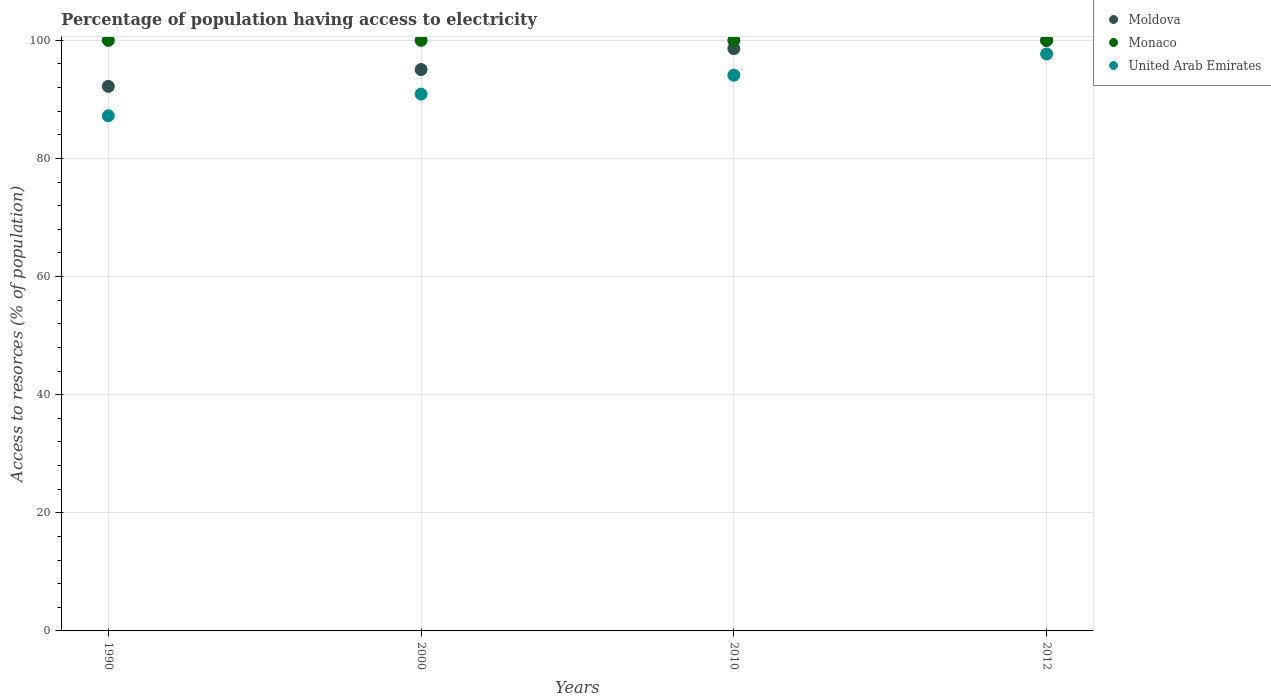Is the number of dotlines equal to the number of legend labels?
Provide a short and direct response. Yes. What is the percentage of population having access to electricity in United Arab Emirates in 2010?
Your answer should be compact. 94.1. Across all years, what is the maximum percentage of population having access to electricity in Moldova?
Keep it short and to the point. 100. Across all years, what is the minimum percentage of population having access to electricity in Monaco?
Ensure brevity in your answer.  100. In which year was the percentage of population having access to electricity in Moldova maximum?
Make the answer very short. 2012. In which year was the percentage of population having access to electricity in United Arab Emirates minimum?
Your answer should be compact. 1990. What is the total percentage of population having access to electricity in United Arab Emirates in the graph?
Your response must be concise. 369.92. What is the difference between the percentage of population having access to electricity in Monaco in 1990 and that in 2010?
Your response must be concise. 0. What is the difference between the percentage of population having access to electricity in Monaco in 2000 and the percentage of population having access to electricity in United Arab Emirates in 2012?
Make the answer very short. 2.3. What is the average percentage of population having access to electricity in Moldova per year?
Provide a succinct answer. 96.47. In the year 1990, what is the difference between the percentage of population having access to electricity in Monaco and percentage of population having access to electricity in United Arab Emirates?
Offer a very short reply. 12.77. In how many years, is the percentage of population having access to electricity in United Arab Emirates greater than 44 %?
Ensure brevity in your answer.  4. Is the difference between the percentage of population having access to electricity in Monaco in 2000 and 2012 greater than the difference between the percentage of population having access to electricity in United Arab Emirates in 2000 and 2012?
Your response must be concise. Yes. What is the difference between the highest and the second highest percentage of population having access to electricity in Moldova?
Ensure brevity in your answer.  1.4. What is the difference between the highest and the lowest percentage of population having access to electricity in United Arab Emirates?
Your answer should be compact. 10.47. Is it the case that in every year, the sum of the percentage of population having access to electricity in Monaco and percentage of population having access to electricity in United Arab Emirates  is greater than the percentage of population having access to electricity in Moldova?
Make the answer very short. Yes. Is the percentage of population having access to electricity in Moldova strictly less than the percentage of population having access to electricity in United Arab Emirates over the years?
Give a very brief answer. No. What is the difference between two consecutive major ticks on the Y-axis?
Ensure brevity in your answer.  20. Does the graph contain grids?
Provide a short and direct response. Yes. Where does the legend appear in the graph?
Offer a terse response. Top right. What is the title of the graph?
Keep it short and to the point. Percentage of population having access to electricity. Does "Venezuela" appear as one of the legend labels in the graph?
Offer a very short reply. No. What is the label or title of the Y-axis?
Your response must be concise. Access to resorces (% of population). What is the Access to resorces (% of population) of Moldova in 1990?
Your response must be concise. 92.22. What is the Access to resorces (% of population) of United Arab Emirates in 1990?
Ensure brevity in your answer.  87.23. What is the Access to resorces (% of population) of Moldova in 2000?
Keep it short and to the point. 95.06. What is the Access to resorces (% of population) of United Arab Emirates in 2000?
Your answer should be compact. 90.9. What is the Access to resorces (% of population) in Moldova in 2010?
Offer a very short reply. 98.6. What is the Access to resorces (% of population) of Monaco in 2010?
Make the answer very short. 100. What is the Access to resorces (% of population) of United Arab Emirates in 2010?
Offer a very short reply. 94.1. What is the Access to resorces (% of population) of Moldova in 2012?
Your response must be concise. 100. What is the Access to resorces (% of population) of Monaco in 2012?
Keep it short and to the point. 100. What is the Access to resorces (% of population) in United Arab Emirates in 2012?
Your answer should be very brief. 97.7. Across all years, what is the maximum Access to resorces (% of population) of Monaco?
Keep it short and to the point. 100. Across all years, what is the maximum Access to resorces (% of population) of United Arab Emirates?
Provide a succinct answer. 97.7. Across all years, what is the minimum Access to resorces (% of population) in Moldova?
Provide a short and direct response. 92.22. Across all years, what is the minimum Access to resorces (% of population) of United Arab Emirates?
Provide a succinct answer. 87.23. What is the total Access to resorces (% of population) of Moldova in the graph?
Keep it short and to the point. 385.87. What is the total Access to resorces (% of population) of Monaco in the graph?
Offer a very short reply. 400. What is the total Access to resorces (% of population) of United Arab Emirates in the graph?
Your answer should be compact. 369.92. What is the difference between the Access to resorces (% of population) of Moldova in 1990 and that in 2000?
Make the answer very short. -2.84. What is the difference between the Access to resorces (% of population) in United Arab Emirates in 1990 and that in 2000?
Your answer should be compact. -3.67. What is the difference between the Access to resorces (% of population) in Moldova in 1990 and that in 2010?
Offer a terse response. -6.38. What is the difference between the Access to resorces (% of population) in Monaco in 1990 and that in 2010?
Ensure brevity in your answer.  0. What is the difference between the Access to resorces (% of population) of United Arab Emirates in 1990 and that in 2010?
Give a very brief answer. -6.87. What is the difference between the Access to resorces (% of population) in Moldova in 1990 and that in 2012?
Ensure brevity in your answer.  -7.78. What is the difference between the Access to resorces (% of population) of Monaco in 1990 and that in 2012?
Provide a succinct answer. 0. What is the difference between the Access to resorces (% of population) in United Arab Emirates in 1990 and that in 2012?
Provide a succinct answer. -10.47. What is the difference between the Access to resorces (% of population) in Moldova in 2000 and that in 2010?
Keep it short and to the point. -3.54. What is the difference between the Access to resorces (% of population) in United Arab Emirates in 2000 and that in 2010?
Offer a terse response. -3.2. What is the difference between the Access to resorces (% of population) in Moldova in 2000 and that in 2012?
Your response must be concise. -4.94. What is the difference between the Access to resorces (% of population) in United Arab Emirates in 2000 and that in 2012?
Your answer should be compact. -6.8. What is the difference between the Access to resorces (% of population) in Moldova in 2010 and that in 2012?
Provide a short and direct response. -1.4. What is the difference between the Access to resorces (% of population) in United Arab Emirates in 2010 and that in 2012?
Keep it short and to the point. -3.6. What is the difference between the Access to resorces (% of population) in Moldova in 1990 and the Access to resorces (% of population) in Monaco in 2000?
Your response must be concise. -7.78. What is the difference between the Access to resorces (% of population) of Moldova in 1990 and the Access to resorces (% of population) of United Arab Emirates in 2000?
Provide a succinct answer. 1.32. What is the difference between the Access to resorces (% of population) of Monaco in 1990 and the Access to resorces (% of population) of United Arab Emirates in 2000?
Keep it short and to the point. 9.1. What is the difference between the Access to resorces (% of population) of Moldova in 1990 and the Access to resorces (% of population) of Monaco in 2010?
Your response must be concise. -7.78. What is the difference between the Access to resorces (% of population) in Moldova in 1990 and the Access to resorces (% of population) in United Arab Emirates in 2010?
Your response must be concise. -1.88. What is the difference between the Access to resorces (% of population) in Monaco in 1990 and the Access to resorces (% of population) in United Arab Emirates in 2010?
Ensure brevity in your answer.  5.9. What is the difference between the Access to resorces (% of population) in Moldova in 1990 and the Access to resorces (% of population) in Monaco in 2012?
Provide a succinct answer. -7.78. What is the difference between the Access to resorces (% of population) of Moldova in 1990 and the Access to resorces (% of population) of United Arab Emirates in 2012?
Provide a short and direct response. -5.48. What is the difference between the Access to resorces (% of population) of Monaco in 1990 and the Access to resorces (% of population) of United Arab Emirates in 2012?
Your answer should be very brief. 2.3. What is the difference between the Access to resorces (% of population) of Moldova in 2000 and the Access to resorces (% of population) of Monaco in 2010?
Give a very brief answer. -4.94. What is the difference between the Access to resorces (% of population) in Moldova in 2000 and the Access to resorces (% of population) in United Arab Emirates in 2010?
Ensure brevity in your answer.  0.96. What is the difference between the Access to resorces (% of population) of Moldova in 2000 and the Access to resorces (% of population) of Monaco in 2012?
Ensure brevity in your answer.  -4.94. What is the difference between the Access to resorces (% of population) in Moldova in 2000 and the Access to resorces (% of population) in United Arab Emirates in 2012?
Provide a succinct answer. -2.64. What is the difference between the Access to resorces (% of population) of Monaco in 2000 and the Access to resorces (% of population) of United Arab Emirates in 2012?
Give a very brief answer. 2.3. What is the difference between the Access to resorces (% of population) in Moldova in 2010 and the Access to resorces (% of population) in Monaco in 2012?
Offer a terse response. -1.4. What is the difference between the Access to resorces (% of population) of Moldova in 2010 and the Access to resorces (% of population) of United Arab Emirates in 2012?
Offer a very short reply. 0.9. What is the difference between the Access to resorces (% of population) of Monaco in 2010 and the Access to resorces (% of population) of United Arab Emirates in 2012?
Ensure brevity in your answer.  2.3. What is the average Access to resorces (% of population) of Moldova per year?
Offer a terse response. 96.47. What is the average Access to resorces (% of population) of Monaco per year?
Ensure brevity in your answer.  100. What is the average Access to resorces (% of population) of United Arab Emirates per year?
Your answer should be compact. 92.48. In the year 1990, what is the difference between the Access to resorces (% of population) in Moldova and Access to resorces (% of population) in Monaco?
Give a very brief answer. -7.78. In the year 1990, what is the difference between the Access to resorces (% of population) in Moldova and Access to resorces (% of population) in United Arab Emirates?
Your response must be concise. 4.99. In the year 1990, what is the difference between the Access to resorces (% of population) in Monaco and Access to resorces (% of population) in United Arab Emirates?
Your answer should be very brief. 12.77. In the year 2000, what is the difference between the Access to resorces (% of population) of Moldova and Access to resorces (% of population) of Monaco?
Offer a very short reply. -4.94. In the year 2000, what is the difference between the Access to resorces (% of population) in Moldova and Access to resorces (% of population) in United Arab Emirates?
Provide a short and direct response. 4.16. In the year 2000, what is the difference between the Access to resorces (% of population) of Monaco and Access to resorces (% of population) of United Arab Emirates?
Give a very brief answer. 9.1. In the year 2010, what is the difference between the Access to resorces (% of population) in Moldova and Access to resorces (% of population) in Monaco?
Provide a short and direct response. -1.4. In the year 2010, what is the difference between the Access to resorces (% of population) of Monaco and Access to resorces (% of population) of United Arab Emirates?
Ensure brevity in your answer.  5.9. In the year 2012, what is the difference between the Access to resorces (% of population) in Moldova and Access to resorces (% of population) in United Arab Emirates?
Ensure brevity in your answer.  2.3. In the year 2012, what is the difference between the Access to resorces (% of population) of Monaco and Access to resorces (% of population) of United Arab Emirates?
Ensure brevity in your answer.  2.3. What is the ratio of the Access to resorces (% of population) in Moldova in 1990 to that in 2000?
Keep it short and to the point. 0.97. What is the ratio of the Access to resorces (% of population) in Monaco in 1990 to that in 2000?
Keep it short and to the point. 1. What is the ratio of the Access to resorces (% of population) of United Arab Emirates in 1990 to that in 2000?
Your answer should be compact. 0.96. What is the ratio of the Access to resorces (% of population) of Moldova in 1990 to that in 2010?
Ensure brevity in your answer.  0.94. What is the ratio of the Access to resorces (% of population) of United Arab Emirates in 1990 to that in 2010?
Your answer should be compact. 0.93. What is the ratio of the Access to resorces (% of population) of Moldova in 1990 to that in 2012?
Ensure brevity in your answer.  0.92. What is the ratio of the Access to resorces (% of population) of Monaco in 1990 to that in 2012?
Provide a short and direct response. 1. What is the ratio of the Access to resorces (% of population) in United Arab Emirates in 1990 to that in 2012?
Ensure brevity in your answer.  0.89. What is the ratio of the Access to resorces (% of population) of Moldova in 2000 to that in 2010?
Offer a terse response. 0.96. What is the ratio of the Access to resorces (% of population) in Moldova in 2000 to that in 2012?
Provide a short and direct response. 0.95. What is the ratio of the Access to resorces (% of population) of Monaco in 2000 to that in 2012?
Your response must be concise. 1. What is the ratio of the Access to resorces (% of population) in United Arab Emirates in 2000 to that in 2012?
Keep it short and to the point. 0.93. What is the ratio of the Access to resorces (% of population) of United Arab Emirates in 2010 to that in 2012?
Offer a terse response. 0.96. What is the difference between the highest and the second highest Access to resorces (% of population) of Moldova?
Give a very brief answer. 1.4. What is the difference between the highest and the second highest Access to resorces (% of population) of United Arab Emirates?
Your answer should be compact. 3.6. What is the difference between the highest and the lowest Access to resorces (% of population) of Moldova?
Keep it short and to the point. 7.78. What is the difference between the highest and the lowest Access to resorces (% of population) in Monaco?
Ensure brevity in your answer.  0. What is the difference between the highest and the lowest Access to resorces (% of population) in United Arab Emirates?
Offer a very short reply. 10.47. 